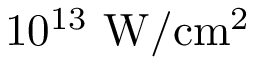Convert formula to latex. <formula><loc_0><loc_0><loc_500><loc_500>1 0 ^ { 1 3 } \ W / c m ^ { 2 }</formula> 